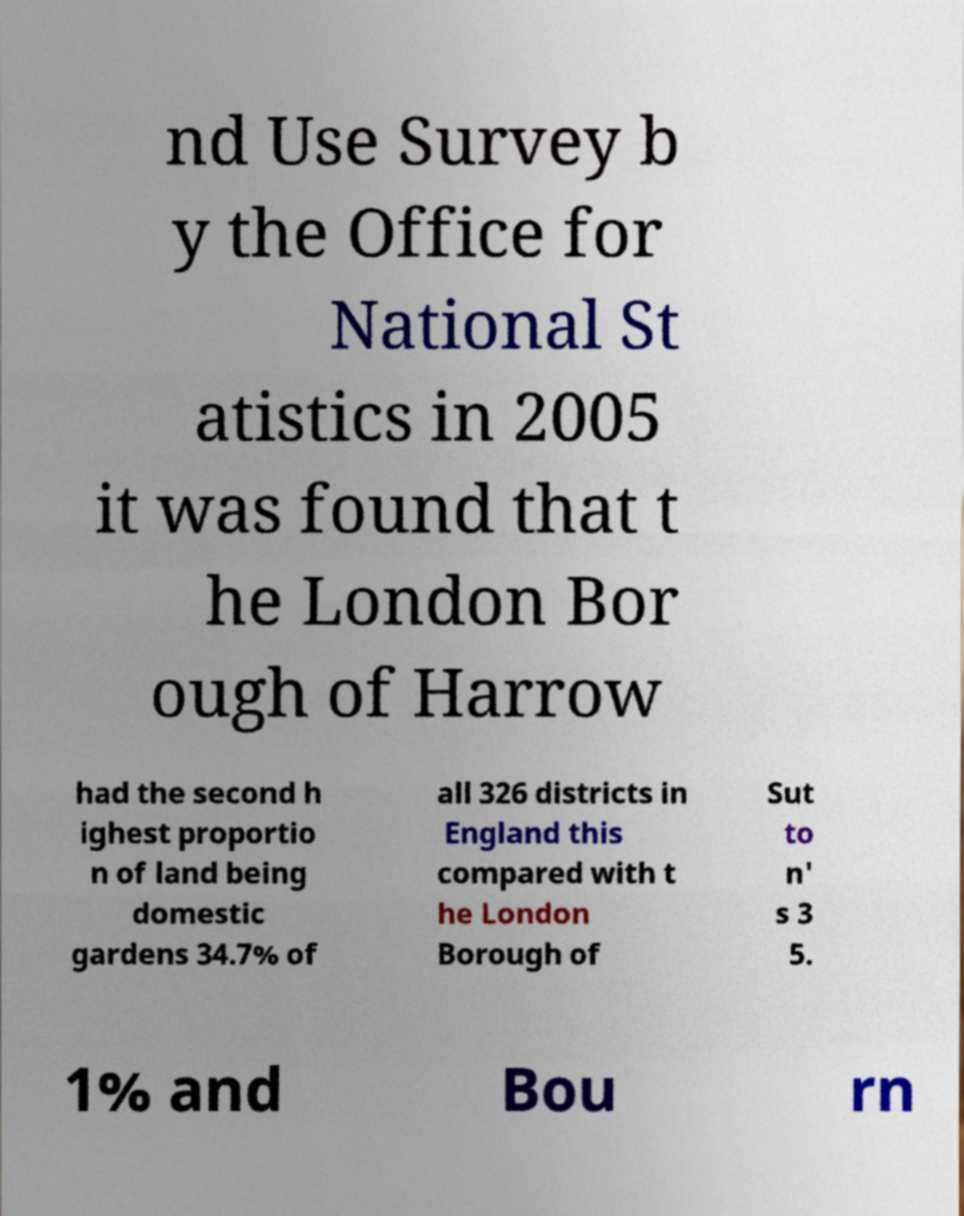Please read and relay the text visible in this image. What does it say? nd Use Survey b y the Office for National St atistics in 2005 it was found that t he London Bor ough of Harrow had the second h ighest proportio n of land being domestic gardens 34.7% of all 326 districts in England this compared with t he London Borough of Sut to n' s 3 5. 1% and Bou rn 